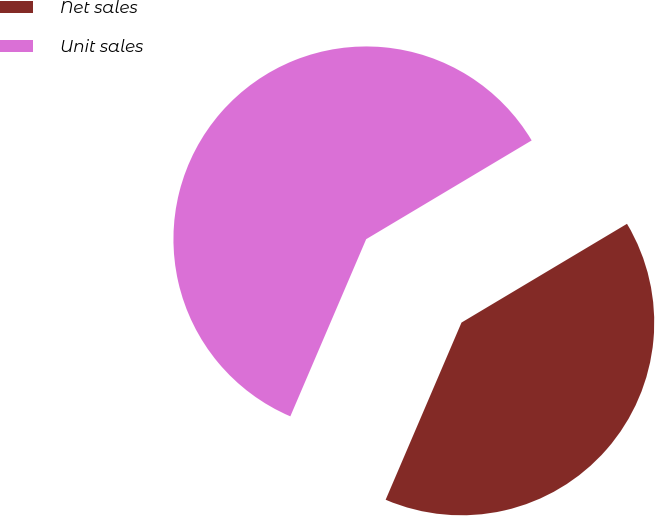<chart> <loc_0><loc_0><loc_500><loc_500><pie_chart><fcel>Net sales<fcel>Unit sales<nl><fcel>40.0%<fcel>60.0%<nl></chart> 